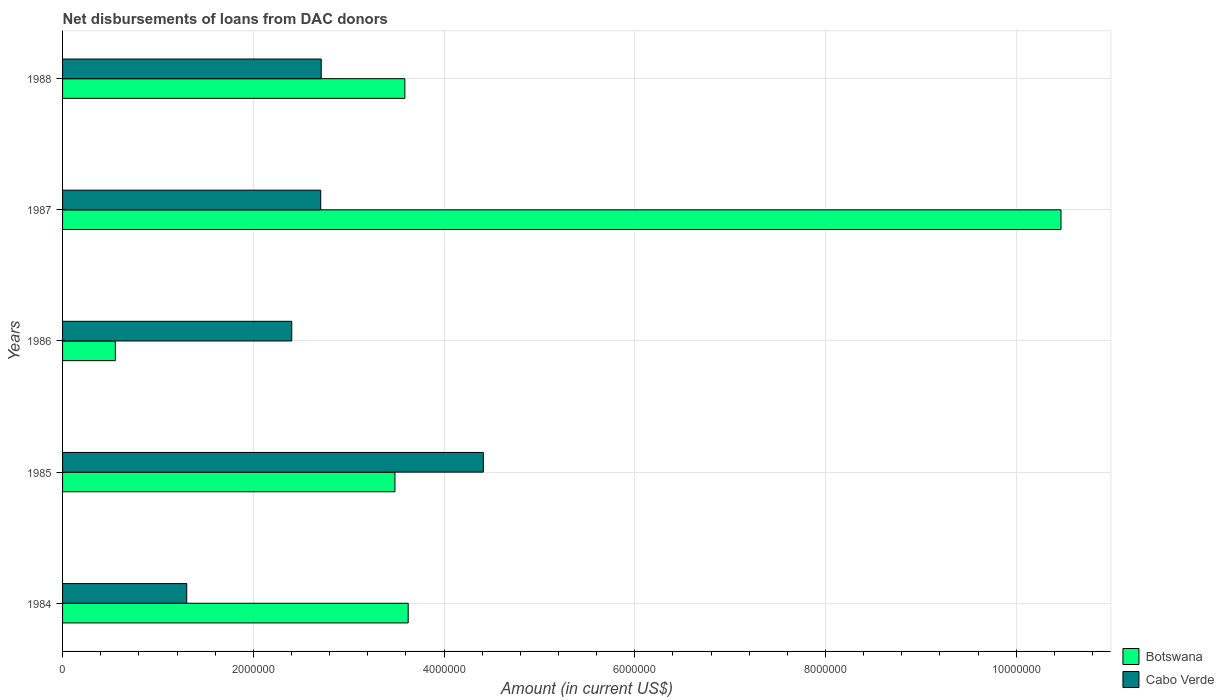Are the number of bars per tick equal to the number of legend labels?
Offer a very short reply. Yes. Are the number of bars on each tick of the Y-axis equal?
Keep it short and to the point. Yes. How many bars are there on the 3rd tick from the top?
Offer a very short reply. 2. What is the label of the 4th group of bars from the top?
Offer a terse response. 1985. What is the amount of loans disbursed in Botswana in 1984?
Provide a short and direct response. 3.62e+06. Across all years, what is the maximum amount of loans disbursed in Botswana?
Provide a short and direct response. 1.05e+07. Across all years, what is the minimum amount of loans disbursed in Cabo Verde?
Make the answer very short. 1.30e+06. In which year was the amount of loans disbursed in Cabo Verde maximum?
Provide a succinct answer. 1985. What is the total amount of loans disbursed in Cabo Verde in the graph?
Make the answer very short. 1.35e+07. What is the difference between the amount of loans disbursed in Cabo Verde in 1984 and that in 1987?
Make the answer very short. -1.40e+06. What is the difference between the amount of loans disbursed in Cabo Verde in 1988 and the amount of loans disbursed in Botswana in 1984?
Ensure brevity in your answer.  -9.12e+05. What is the average amount of loans disbursed in Botswana per year?
Your response must be concise. 4.34e+06. In the year 1987, what is the difference between the amount of loans disbursed in Cabo Verde and amount of loans disbursed in Botswana?
Keep it short and to the point. -7.76e+06. What is the ratio of the amount of loans disbursed in Botswana in 1986 to that in 1987?
Make the answer very short. 0.05. Is the difference between the amount of loans disbursed in Cabo Verde in 1985 and 1987 greater than the difference between the amount of loans disbursed in Botswana in 1985 and 1987?
Ensure brevity in your answer.  Yes. What is the difference between the highest and the second highest amount of loans disbursed in Cabo Verde?
Offer a terse response. 1.70e+06. What is the difference between the highest and the lowest amount of loans disbursed in Cabo Verde?
Keep it short and to the point. 3.11e+06. Is the sum of the amount of loans disbursed in Botswana in 1986 and 1987 greater than the maximum amount of loans disbursed in Cabo Verde across all years?
Offer a terse response. Yes. What does the 1st bar from the top in 1987 represents?
Offer a very short reply. Cabo Verde. What does the 2nd bar from the bottom in 1988 represents?
Provide a short and direct response. Cabo Verde. How many years are there in the graph?
Your answer should be very brief. 5. What is the difference between two consecutive major ticks on the X-axis?
Provide a short and direct response. 2.00e+06. Does the graph contain grids?
Offer a terse response. Yes. Where does the legend appear in the graph?
Give a very brief answer. Bottom right. What is the title of the graph?
Make the answer very short. Net disbursements of loans from DAC donors. What is the label or title of the Y-axis?
Your answer should be compact. Years. What is the Amount (in current US$) in Botswana in 1984?
Provide a succinct answer. 3.62e+06. What is the Amount (in current US$) in Cabo Verde in 1984?
Keep it short and to the point. 1.30e+06. What is the Amount (in current US$) of Botswana in 1985?
Keep it short and to the point. 3.48e+06. What is the Amount (in current US$) in Cabo Verde in 1985?
Your response must be concise. 4.41e+06. What is the Amount (in current US$) of Botswana in 1986?
Your answer should be compact. 5.53e+05. What is the Amount (in current US$) in Cabo Verde in 1986?
Your response must be concise. 2.40e+06. What is the Amount (in current US$) in Botswana in 1987?
Offer a terse response. 1.05e+07. What is the Amount (in current US$) in Cabo Verde in 1987?
Keep it short and to the point. 2.71e+06. What is the Amount (in current US$) in Botswana in 1988?
Make the answer very short. 3.59e+06. What is the Amount (in current US$) in Cabo Verde in 1988?
Provide a succinct answer. 2.71e+06. Across all years, what is the maximum Amount (in current US$) of Botswana?
Ensure brevity in your answer.  1.05e+07. Across all years, what is the maximum Amount (in current US$) in Cabo Verde?
Provide a succinct answer. 4.41e+06. Across all years, what is the minimum Amount (in current US$) in Botswana?
Your answer should be very brief. 5.53e+05. Across all years, what is the minimum Amount (in current US$) of Cabo Verde?
Your answer should be compact. 1.30e+06. What is the total Amount (in current US$) in Botswana in the graph?
Provide a succinct answer. 2.17e+07. What is the total Amount (in current US$) in Cabo Verde in the graph?
Ensure brevity in your answer.  1.35e+07. What is the difference between the Amount (in current US$) of Botswana in 1984 and that in 1985?
Offer a very short reply. 1.39e+05. What is the difference between the Amount (in current US$) of Cabo Verde in 1984 and that in 1985?
Offer a very short reply. -3.11e+06. What is the difference between the Amount (in current US$) of Botswana in 1984 and that in 1986?
Your answer should be very brief. 3.07e+06. What is the difference between the Amount (in current US$) in Cabo Verde in 1984 and that in 1986?
Offer a terse response. -1.10e+06. What is the difference between the Amount (in current US$) of Botswana in 1984 and that in 1987?
Ensure brevity in your answer.  -6.84e+06. What is the difference between the Amount (in current US$) in Cabo Verde in 1984 and that in 1987?
Ensure brevity in your answer.  -1.40e+06. What is the difference between the Amount (in current US$) of Botswana in 1984 and that in 1988?
Your response must be concise. 3.50e+04. What is the difference between the Amount (in current US$) of Cabo Verde in 1984 and that in 1988?
Make the answer very short. -1.41e+06. What is the difference between the Amount (in current US$) in Botswana in 1985 and that in 1986?
Your response must be concise. 2.93e+06. What is the difference between the Amount (in current US$) in Cabo Verde in 1985 and that in 1986?
Ensure brevity in your answer.  2.01e+06. What is the difference between the Amount (in current US$) of Botswana in 1985 and that in 1987?
Provide a short and direct response. -6.98e+06. What is the difference between the Amount (in current US$) in Cabo Verde in 1985 and that in 1987?
Give a very brief answer. 1.70e+06. What is the difference between the Amount (in current US$) of Botswana in 1985 and that in 1988?
Offer a very short reply. -1.04e+05. What is the difference between the Amount (in current US$) in Cabo Verde in 1985 and that in 1988?
Provide a succinct answer. 1.70e+06. What is the difference between the Amount (in current US$) of Botswana in 1986 and that in 1987?
Your answer should be compact. -9.92e+06. What is the difference between the Amount (in current US$) of Cabo Verde in 1986 and that in 1987?
Give a very brief answer. -3.04e+05. What is the difference between the Amount (in current US$) in Botswana in 1986 and that in 1988?
Your answer should be very brief. -3.04e+06. What is the difference between the Amount (in current US$) of Cabo Verde in 1986 and that in 1988?
Offer a terse response. -3.09e+05. What is the difference between the Amount (in current US$) of Botswana in 1987 and that in 1988?
Your answer should be compact. 6.88e+06. What is the difference between the Amount (in current US$) of Cabo Verde in 1987 and that in 1988?
Provide a short and direct response. -5000. What is the difference between the Amount (in current US$) in Botswana in 1984 and the Amount (in current US$) in Cabo Verde in 1985?
Give a very brief answer. -7.88e+05. What is the difference between the Amount (in current US$) of Botswana in 1984 and the Amount (in current US$) of Cabo Verde in 1986?
Provide a succinct answer. 1.22e+06. What is the difference between the Amount (in current US$) of Botswana in 1984 and the Amount (in current US$) of Cabo Verde in 1987?
Offer a very short reply. 9.17e+05. What is the difference between the Amount (in current US$) in Botswana in 1984 and the Amount (in current US$) in Cabo Verde in 1988?
Your answer should be very brief. 9.12e+05. What is the difference between the Amount (in current US$) in Botswana in 1985 and the Amount (in current US$) in Cabo Verde in 1986?
Keep it short and to the point. 1.08e+06. What is the difference between the Amount (in current US$) in Botswana in 1985 and the Amount (in current US$) in Cabo Verde in 1987?
Your answer should be compact. 7.78e+05. What is the difference between the Amount (in current US$) of Botswana in 1985 and the Amount (in current US$) of Cabo Verde in 1988?
Your response must be concise. 7.73e+05. What is the difference between the Amount (in current US$) in Botswana in 1986 and the Amount (in current US$) in Cabo Verde in 1987?
Your response must be concise. -2.15e+06. What is the difference between the Amount (in current US$) of Botswana in 1986 and the Amount (in current US$) of Cabo Verde in 1988?
Your response must be concise. -2.16e+06. What is the difference between the Amount (in current US$) of Botswana in 1987 and the Amount (in current US$) of Cabo Verde in 1988?
Make the answer very short. 7.76e+06. What is the average Amount (in current US$) of Botswana per year?
Ensure brevity in your answer.  4.34e+06. What is the average Amount (in current US$) in Cabo Verde per year?
Give a very brief answer. 2.71e+06. In the year 1984, what is the difference between the Amount (in current US$) of Botswana and Amount (in current US$) of Cabo Verde?
Provide a short and direct response. 2.32e+06. In the year 1985, what is the difference between the Amount (in current US$) in Botswana and Amount (in current US$) in Cabo Verde?
Make the answer very short. -9.27e+05. In the year 1986, what is the difference between the Amount (in current US$) in Botswana and Amount (in current US$) in Cabo Verde?
Provide a succinct answer. -1.85e+06. In the year 1987, what is the difference between the Amount (in current US$) in Botswana and Amount (in current US$) in Cabo Verde?
Ensure brevity in your answer.  7.76e+06. In the year 1988, what is the difference between the Amount (in current US$) of Botswana and Amount (in current US$) of Cabo Verde?
Provide a short and direct response. 8.77e+05. What is the ratio of the Amount (in current US$) of Botswana in 1984 to that in 1985?
Your response must be concise. 1.04. What is the ratio of the Amount (in current US$) of Cabo Verde in 1984 to that in 1985?
Give a very brief answer. 0.3. What is the ratio of the Amount (in current US$) of Botswana in 1984 to that in 1986?
Ensure brevity in your answer.  6.55. What is the ratio of the Amount (in current US$) in Cabo Verde in 1984 to that in 1986?
Your answer should be compact. 0.54. What is the ratio of the Amount (in current US$) of Botswana in 1984 to that in 1987?
Provide a succinct answer. 0.35. What is the ratio of the Amount (in current US$) of Cabo Verde in 1984 to that in 1987?
Keep it short and to the point. 0.48. What is the ratio of the Amount (in current US$) in Botswana in 1984 to that in 1988?
Provide a succinct answer. 1.01. What is the ratio of the Amount (in current US$) of Cabo Verde in 1984 to that in 1988?
Provide a succinct answer. 0.48. What is the ratio of the Amount (in current US$) in Botswana in 1985 to that in 1986?
Keep it short and to the point. 6.3. What is the ratio of the Amount (in current US$) in Cabo Verde in 1985 to that in 1986?
Offer a terse response. 1.84. What is the ratio of the Amount (in current US$) in Botswana in 1985 to that in 1987?
Provide a short and direct response. 0.33. What is the ratio of the Amount (in current US$) of Cabo Verde in 1985 to that in 1987?
Provide a short and direct response. 1.63. What is the ratio of the Amount (in current US$) of Botswana in 1985 to that in 1988?
Offer a terse response. 0.97. What is the ratio of the Amount (in current US$) of Cabo Verde in 1985 to that in 1988?
Your answer should be compact. 1.63. What is the ratio of the Amount (in current US$) of Botswana in 1986 to that in 1987?
Ensure brevity in your answer.  0.05. What is the ratio of the Amount (in current US$) in Cabo Verde in 1986 to that in 1987?
Provide a short and direct response. 0.89. What is the ratio of the Amount (in current US$) of Botswana in 1986 to that in 1988?
Your answer should be compact. 0.15. What is the ratio of the Amount (in current US$) of Cabo Verde in 1986 to that in 1988?
Provide a succinct answer. 0.89. What is the ratio of the Amount (in current US$) of Botswana in 1987 to that in 1988?
Ensure brevity in your answer.  2.92. What is the ratio of the Amount (in current US$) of Cabo Verde in 1987 to that in 1988?
Offer a very short reply. 1. What is the difference between the highest and the second highest Amount (in current US$) in Botswana?
Provide a short and direct response. 6.84e+06. What is the difference between the highest and the second highest Amount (in current US$) in Cabo Verde?
Offer a terse response. 1.70e+06. What is the difference between the highest and the lowest Amount (in current US$) of Botswana?
Keep it short and to the point. 9.92e+06. What is the difference between the highest and the lowest Amount (in current US$) of Cabo Verde?
Your answer should be compact. 3.11e+06. 